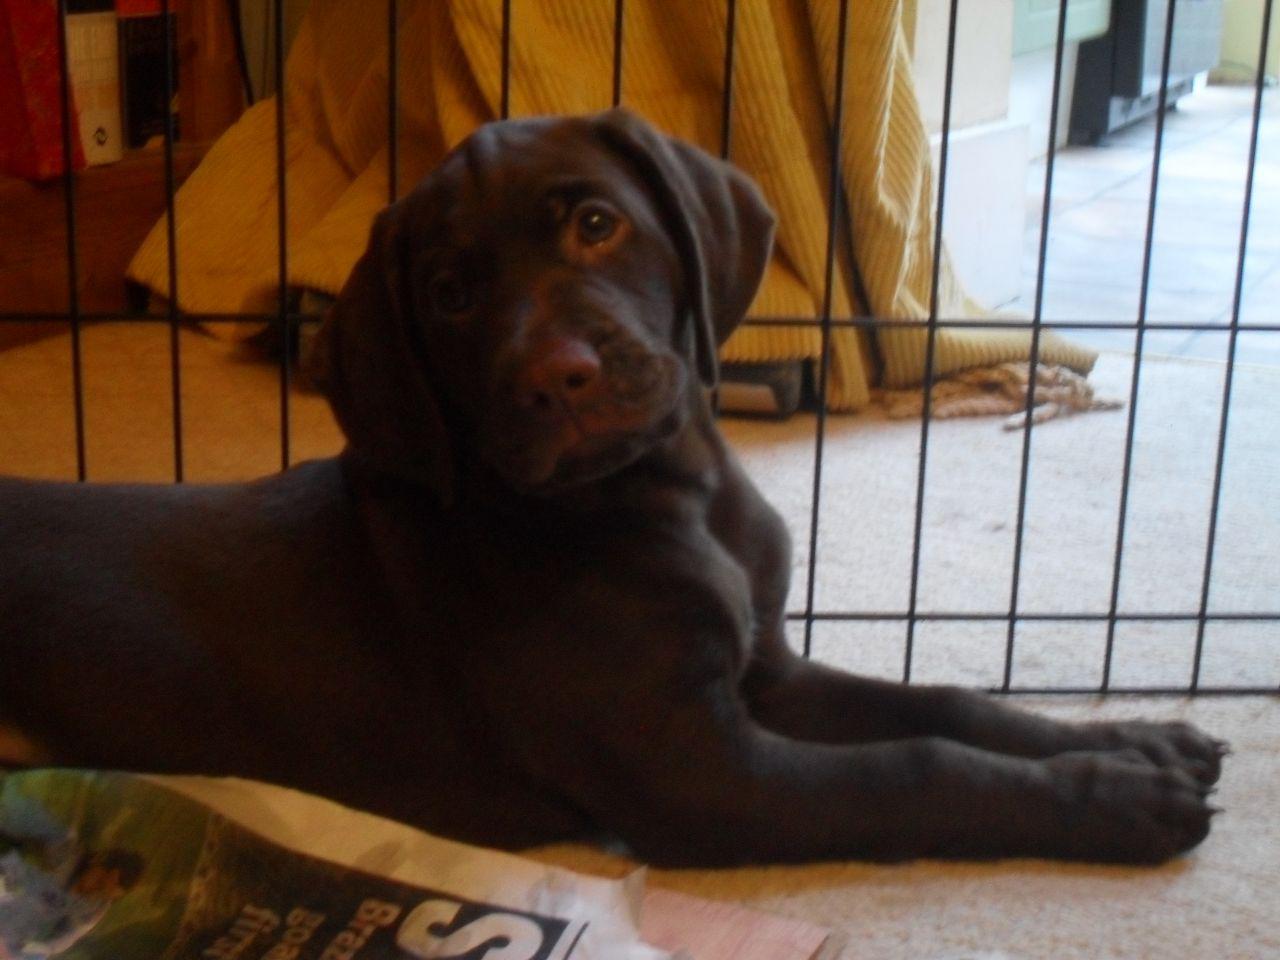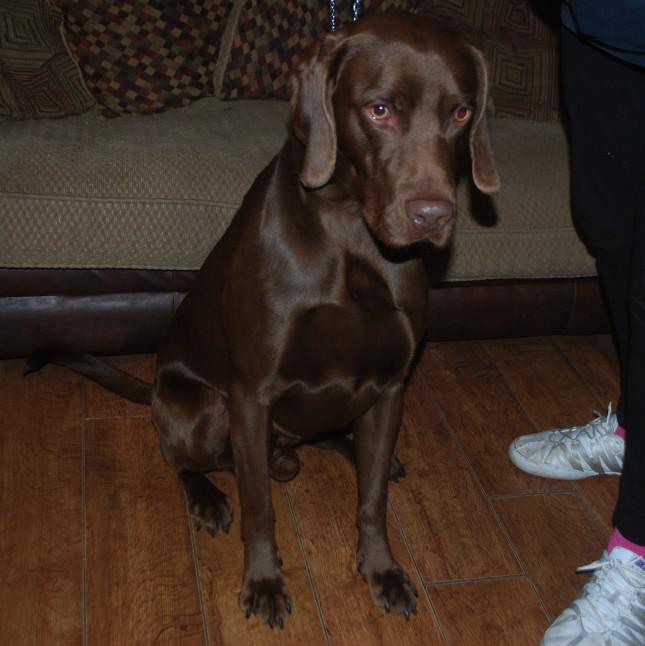The first image is the image on the left, the second image is the image on the right. Considering the images on both sides, is "One brown dog is sitting upright on a wood floor, and the other brown dog is reclining with its body in profile but its head turned to the camera." valid? Answer yes or no. Yes. The first image is the image on the left, the second image is the image on the right. For the images displayed, is the sentence "A dog in one of the images is sitting on a wooden floor." factually correct? Answer yes or no. Yes. 